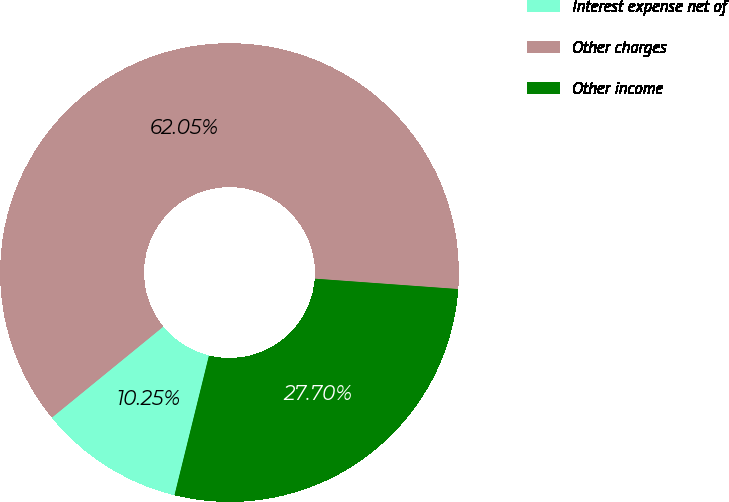<chart> <loc_0><loc_0><loc_500><loc_500><pie_chart><fcel>Interest expense net of<fcel>Other charges<fcel>Other income<nl><fcel>10.25%<fcel>62.05%<fcel>27.7%<nl></chart> 